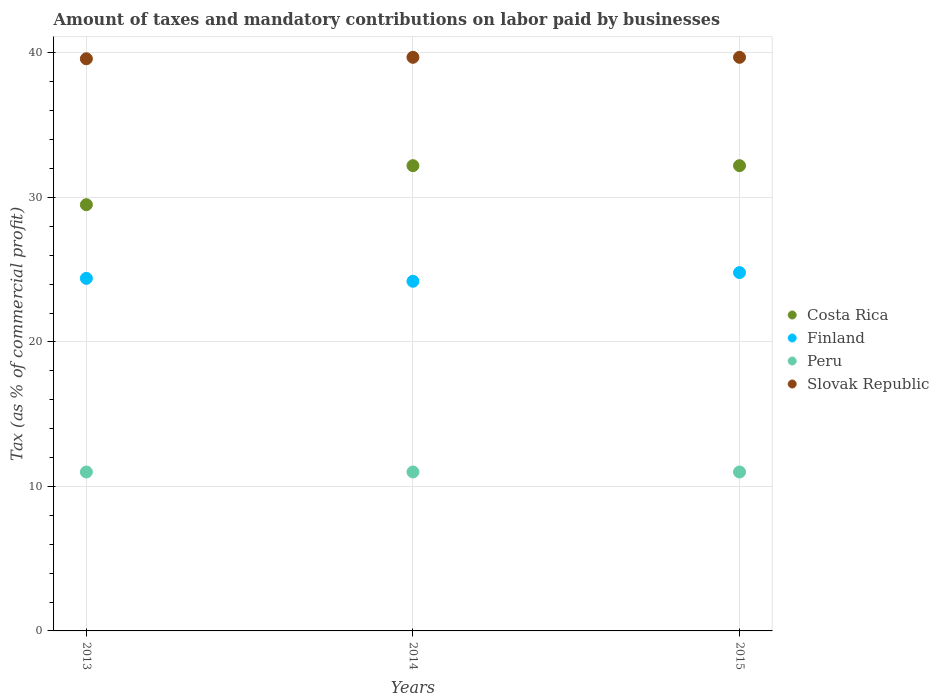Is the number of dotlines equal to the number of legend labels?
Provide a succinct answer. Yes. What is the percentage of taxes paid by businesses in Slovak Republic in 2013?
Your answer should be compact. 39.6. Across all years, what is the maximum percentage of taxes paid by businesses in Costa Rica?
Your response must be concise. 32.2. Across all years, what is the minimum percentage of taxes paid by businesses in Peru?
Provide a succinct answer. 11. In which year was the percentage of taxes paid by businesses in Finland maximum?
Your response must be concise. 2015. In which year was the percentage of taxes paid by businesses in Peru minimum?
Provide a short and direct response. 2013. What is the total percentage of taxes paid by businesses in Peru in the graph?
Your answer should be very brief. 33. What is the difference between the percentage of taxes paid by businesses in Slovak Republic in 2013 and that in 2014?
Offer a very short reply. -0.1. What is the difference between the percentage of taxes paid by businesses in Slovak Republic in 2015 and the percentage of taxes paid by businesses in Peru in 2014?
Offer a very short reply. 28.7. What is the average percentage of taxes paid by businesses in Costa Rica per year?
Offer a terse response. 31.3. In the year 2015, what is the difference between the percentage of taxes paid by businesses in Slovak Republic and percentage of taxes paid by businesses in Peru?
Keep it short and to the point. 28.7. What is the ratio of the percentage of taxes paid by businesses in Costa Rica in 2014 to that in 2015?
Keep it short and to the point. 1. Is the percentage of taxes paid by businesses in Peru in 2013 less than that in 2014?
Your response must be concise. No. Is the difference between the percentage of taxes paid by businesses in Slovak Republic in 2014 and 2015 greater than the difference between the percentage of taxes paid by businesses in Peru in 2014 and 2015?
Offer a very short reply. No. What is the difference between the highest and the second highest percentage of taxes paid by businesses in Peru?
Your response must be concise. 0. What is the difference between the highest and the lowest percentage of taxes paid by businesses in Slovak Republic?
Your response must be concise. 0.1. Is the sum of the percentage of taxes paid by businesses in Finland in 2014 and 2015 greater than the maximum percentage of taxes paid by businesses in Slovak Republic across all years?
Offer a terse response. Yes. Is it the case that in every year, the sum of the percentage of taxes paid by businesses in Peru and percentage of taxes paid by businesses in Costa Rica  is greater than the sum of percentage of taxes paid by businesses in Finland and percentage of taxes paid by businesses in Slovak Republic?
Your answer should be compact. Yes. Is it the case that in every year, the sum of the percentage of taxes paid by businesses in Peru and percentage of taxes paid by businesses in Costa Rica  is greater than the percentage of taxes paid by businesses in Finland?
Your answer should be very brief. Yes. Does the percentage of taxes paid by businesses in Slovak Republic monotonically increase over the years?
Your answer should be compact. No. Is the percentage of taxes paid by businesses in Finland strictly less than the percentage of taxes paid by businesses in Costa Rica over the years?
Keep it short and to the point. Yes. What is the difference between two consecutive major ticks on the Y-axis?
Keep it short and to the point. 10. Are the values on the major ticks of Y-axis written in scientific E-notation?
Your answer should be very brief. No. Does the graph contain any zero values?
Keep it short and to the point. No. Does the graph contain grids?
Your response must be concise. Yes. How many legend labels are there?
Offer a terse response. 4. What is the title of the graph?
Give a very brief answer. Amount of taxes and mandatory contributions on labor paid by businesses. Does "Guam" appear as one of the legend labels in the graph?
Make the answer very short. No. What is the label or title of the Y-axis?
Provide a short and direct response. Tax (as % of commercial profit). What is the Tax (as % of commercial profit) of Costa Rica in 2013?
Make the answer very short. 29.5. What is the Tax (as % of commercial profit) in Finland in 2013?
Give a very brief answer. 24.4. What is the Tax (as % of commercial profit) in Slovak Republic in 2013?
Provide a succinct answer. 39.6. What is the Tax (as % of commercial profit) of Costa Rica in 2014?
Your response must be concise. 32.2. What is the Tax (as % of commercial profit) in Finland in 2014?
Your answer should be very brief. 24.2. What is the Tax (as % of commercial profit) of Slovak Republic in 2014?
Keep it short and to the point. 39.7. What is the Tax (as % of commercial profit) of Costa Rica in 2015?
Provide a short and direct response. 32.2. What is the Tax (as % of commercial profit) in Finland in 2015?
Give a very brief answer. 24.8. What is the Tax (as % of commercial profit) in Slovak Republic in 2015?
Your answer should be compact. 39.7. Across all years, what is the maximum Tax (as % of commercial profit) of Costa Rica?
Provide a succinct answer. 32.2. Across all years, what is the maximum Tax (as % of commercial profit) in Finland?
Keep it short and to the point. 24.8. Across all years, what is the maximum Tax (as % of commercial profit) of Peru?
Offer a very short reply. 11. Across all years, what is the maximum Tax (as % of commercial profit) of Slovak Republic?
Your response must be concise. 39.7. Across all years, what is the minimum Tax (as % of commercial profit) in Costa Rica?
Ensure brevity in your answer.  29.5. Across all years, what is the minimum Tax (as % of commercial profit) of Finland?
Provide a short and direct response. 24.2. Across all years, what is the minimum Tax (as % of commercial profit) of Peru?
Give a very brief answer. 11. Across all years, what is the minimum Tax (as % of commercial profit) of Slovak Republic?
Ensure brevity in your answer.  39.6. What is the total Tax (as % of commercial profit) of Costa Rica in the graph?
Make the answer very short. 93.9. What is the total Tax (as % of commercial profit) in Finland in the graph?
Give a very brief answer. 73.4. What is the total Tax (as % of commercial profit) of Slovak Republic in the graph?
Provide a succinct answer. 119. What is the difference between the Tax (as % of commercial profit) in Costa Rica in 2013 and that in 2014?
Offer a very short reply. -2.7. What is the difference between the Tax (as % of commercial profit) of Finland in 2013 and that in 2014?
Your answer should be compact. 0.2. What is the difference between the Tax (as % of commercial profit) in Peru in 2013 and that in 2014?
Your response must be concise. 0. What is the difference between the Tax (as % of commercial profit) in Costa Rica in 2013 and that in 2015?
Ensure brevity in your answer.  -2.7. What is the difference between the Tax (as % of commercial profit) in Finland in 2013 and that in 2015?
Keep it short and to the point. -0.4. What is the difference between the Tax (as % of commercial profit) in Peru in 2013 and that in 2015?
Make the answer very short. 0. What is the difference between the Tax (as % of commercial profit) of Slovak Republic in 2013 and that in 2015?
Your answer should be compact. -0.1. What is the difference between the Tax (as % of commercial profit) in Costa Rica in 2014 and that in 2015?
Provide a succinct answer. 0. What is the difference between the Tax (as % of commercial profit) of Finland in 2014 and that in 2015?
Offer a terse response. -0.6. What is the difference between the Tax (as % of commercial profit) of Peru in 2014 and that in 2015?
Your answer should be compact. 0. What is the difference between the Tax (as % of commercial profit) in Slovak Republic in 2014 and that in 2015?
Give a very brief answer. 0. What is the difference between the Tax (as % of commercial profit) of Costa Rica in 2013 and the Tax (as % of commercial profit) of Slovak Republic in 2014?
Provide a short and direct response. -10.2. What is the difference between the Tax (as % of commercial profit) in Finland in 2013 and the Tax (as % of commercial profit) in Peru in 2014?
Ensure brevity in your answer.  13.4. What is the difference between the Tax (as % of commercial profit) in Finland in 2013 and the Tax (as % of commercial profit) in Slovak Republic in 2014?
Your answer should be very brief. -15.3. What is the difference between the Tax (as % of commercial profit) in Peru in 2013 and the Tax (as % of commercial profit) in Slovak Republic in 2014?
Your answer should be very brief. -28.7. What is the difference between the Tax (as % of commercial profit) of Costa Rica in 2013 and the Tax (as % of commercial profit) of Slovak Republic in 2015?
Offer a terse response. -10.2. What is the difference between the Tax (as % of commercial profit) in Finland in 2013 and the Tax (as % of commercial profit) in Peru in 2015?
Keep it short and to the point. 13.4. What is the difference between the Tax (as % of commercial profit) of Finland in 2013 and the Tax (as % of commercial profit) of Slovak Republic in 2015?
Keep it short and to the point. -15.3. What is the difference between the Tax (as % of commercial profit) in Peru in 2013 and the Tax (as % of commercial profit) in Slovak Republic in 2015?
Give a very brief answer. -28.7. What is the difference between the Tax (as % of commercial profit) in Costa Rica in 2014 and the Tax (as % of commercial profit) in Finland in 2015?
Give a very brief answer. 7.4. What is the difference between the Tax (as % of commercial profit) in Costa Rica in 2014 and the Tax (as % of commercial profit) in Peru in 2015?
Give a very brief answer. 21.2. What is the difference between the Tax (as % of commercial profit) in Costa Rica in 2014 and the Tax (as % of commercial profit) in Slovak Republic in 2015?
Your response must be concise. -7.5. What is the difference between the Tax (as % of commercial profit) in Finland in 2014 and the Tax (as % of commercial profit) in Peru in 2015?
Your answer should be compact. 13.2. What is the difference between the Tax (as % of commercial profit) in Finland in 2014 and the Tax (as % of commercial profit) in Slovak Republic in 2015?
Ensure brevity in your answer.  -15.5. What is the difference between the Tax (as % of commercial profit) in Peru in 2014 and the Tax (as % of commercial profit) in Slovak Republic in 2015?
Your answer should be very brief. -28.7. What is the average Tax (as % of commercial profit) of Costa Rica per year?
Give a very brief answer. 31.3. What is the average Tax (as % of commercial profit) in Finland per year?
Provide a succinct answer. 24.47. What is the average Tax (as % of commercial profit) in Peru per year?
Ensure brevity in your answer.  11. What is the average Tax (as % of commercial profit) in Slovak Republic per year?
Provide a short and direct response. 39.67. In the year 2013, what is the difference between the Tax (as % of commercial profit) of Costa Rica and Tax (as % of commercial profit) of Peru?
Ensure brevity in your answer.  18.5. In the year 2013, what is the difference between the Tax (as % of commercial profit) of Finland and Tax (as % of commercial profit) of Slovak Republic?
Offer a terse response. -15.2. In the year 2013, what is the difference between the Tax (as % of commercial profit) in Peru and Tax (as % of commercial profit) in Slovak Republic?
Give a very brief answer. -28.6. In the year 2014, what is the difference between the Tax (as % of commercial profit) in Costa Rica and Tax (as % of commercial profit) in Finland?
Keep it short and to the point. 8. In the year 2014, what is the difference between the Tax (as % of commercial profit) of Costa Rica and Tax (as % of commercial profit) of Peru?
Offer a very short reply. 21.2. In the year 2014, what is the difference between the Tax (as % of commercial profit) in Costa Rica and Tax (as % of commercial profit) in Slovak Republic?
Offer a very short reply. -7.5. In the year 2014, what is the difference between the Tax (as % of commercial profit) of Finland and Tax (as % of commercial profit) of Slovak Republic?
Provide a short and direct response. -15.5. In the year 2014, what is the difference between the Tax (as % of commercial profit) of Peru and Tax (as % of commercial profit) of Slovak Republic?
Offer a very short reply. -28.7. In the year 2015, what is the difference between the Tax (as % of commercial profit) of Costa Rica and Tax (as % of commercial profit) of Peru?
Provide a short and direct response. 21.2. In the year 2015, what is the difference between the Tax (as % of commercial profit) in Finland and Tax (as % of commercial profit) in Peru?
Make the answer very short. 13.8. In the year 2015, what is the difference between the Tax (as % of commercial profit) in Finland and Tax (as % of commercial profit) in Slovak Republic?
Make the answer very short. -14.9. In the year 2015, what is the difference between the Tax (as % of commercial profit) of Peru and Tax (as % of commercial profit) of Slovak Republic?
Provide a succinct answer. -28.7. What is the ratio of the Tax (as % of commercial profit) of Costa Rica in 2013 to that in 2014?
Provide a succinct answer. 0.92. What is the ratio of the Tax (as % of commercial profit) in Finland in 2013 to that in 2014?
Make the answer very short. 1.01. What is the ratio of the Tax (as % of commercial profit) of Peru in 2013 to that in 2014?
Your answer should be very brief. 1. What is the ratio of the Tax (as % of commercial profit) in Costa Rica in 2013 to that in 2015?
Offer a terse response. 0.92. What is the ratio of the Tax (as % of commercial profit) of Finland in 2013 to that in 2015?
Offer a very short reply. 0.98. What is the ratio of the Tax (as % of commercial profit) of Finland in 2014 to that in 2015?
Your answer should be very brief. 0.98. What is the difference between the highest and the second highest Tax (as % of commercial profit) in Peru?
Ensure brevity in your answer.  0. What is the difference between the highest and the lowest Tax (as % of commercial profit) of Peru?
Your response must be concise. 0. What is the difference between the highest and the lowest Tax (as % of commercial profit) in Slovak Republic?
Provide a short and direct response. 0.1. 